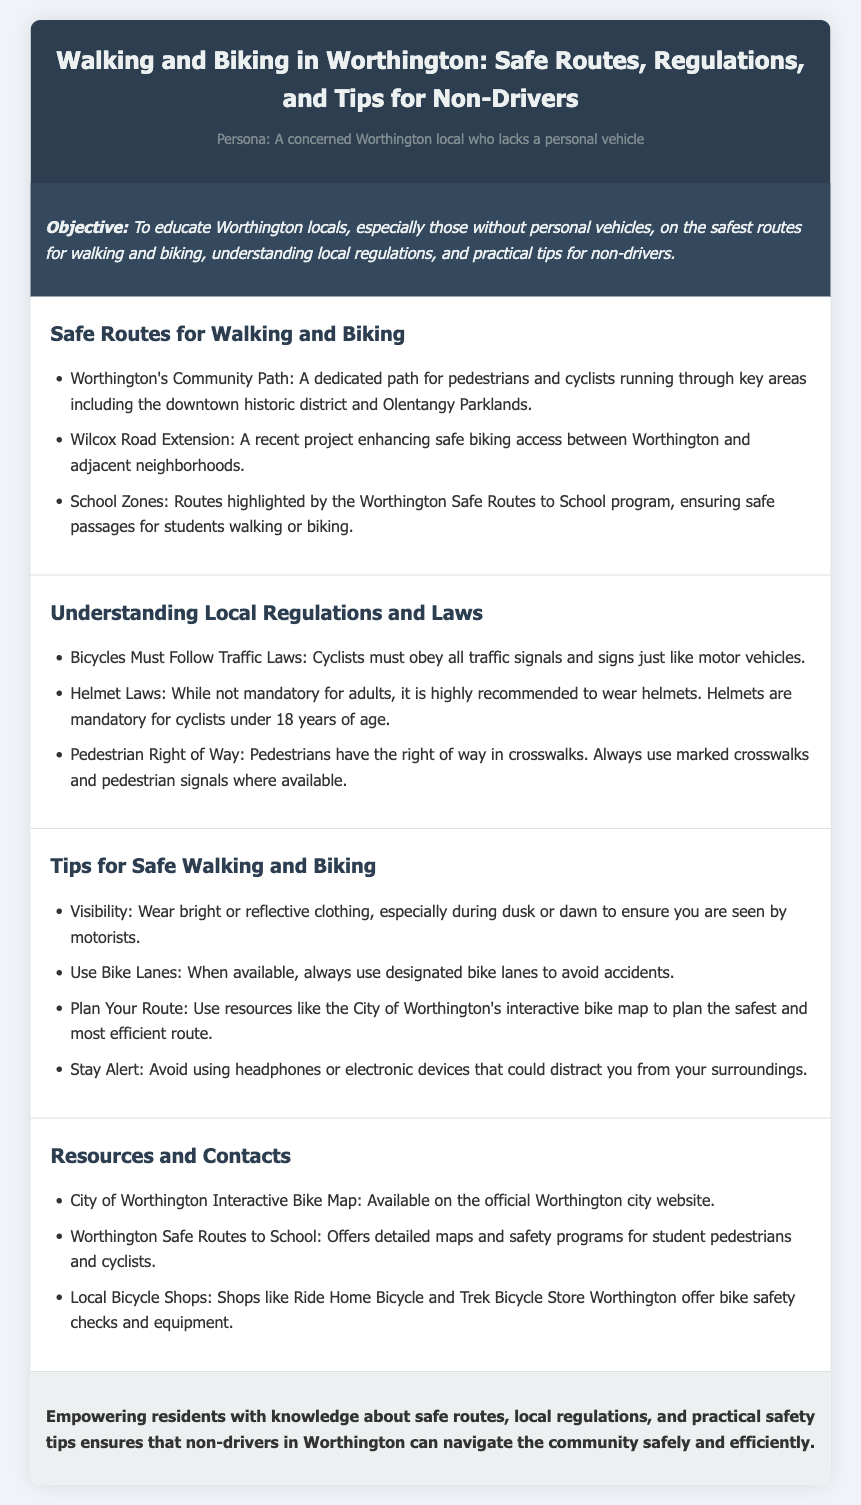what is the objective of the lesson plan? The objective is to educate Worthington locals, especially those without personal vehicles, on the safest routes for walking and biking, understanding local regulations, and practical tips for non-drivers.
Answer: to educate Worthington locals on safe routes, regulations, and tips what are the names of two safe routes mentioned? The document provides specific routes for walking and biking; two routes are the Worthington's Community Path and Wilcox Road Extension.
Answer: Worthington's Community Path, Wilcox Road Extension what law regarding helmets applies to cyclists under 18? The document states that helmets are mandatory for cyclists under 18 years of age.
Answer: mandatory what is one tip for visibility while walking or biking? The lesson plan offers practical safety tips; one tip is to wear bright or reflective clothing, especially during dusk or dawn.
Answer: wear bright or reflective clothing where can one find the City of Worthington Interactive Bike Map? The resource for the interactive bike map is detailed in the lesson plan, indicating it is available on the official Worthington city website.
Answer: official Worthington city website how many main sections does the document have? The structure of the lesson plan includes sections on Safe Routes, Regulations, Tips, and Resources, totaling four main sections.
Answer: four why is it recommended to plan your route? The lesson plan suggests planning your route using resources like the City of Worthington's interactive bike map to ensure safety and efficiency.
Answer: to ensure safety and efficiency what is the conclusion of the lesson plan? The conclusion summarizes the importance of empowering residents with knowledge about safe routes, regulations, and practical safety tips for non-drivers.
Answer: Empowering residents with knowledge about safe routes, regulations, and practical safety tips 